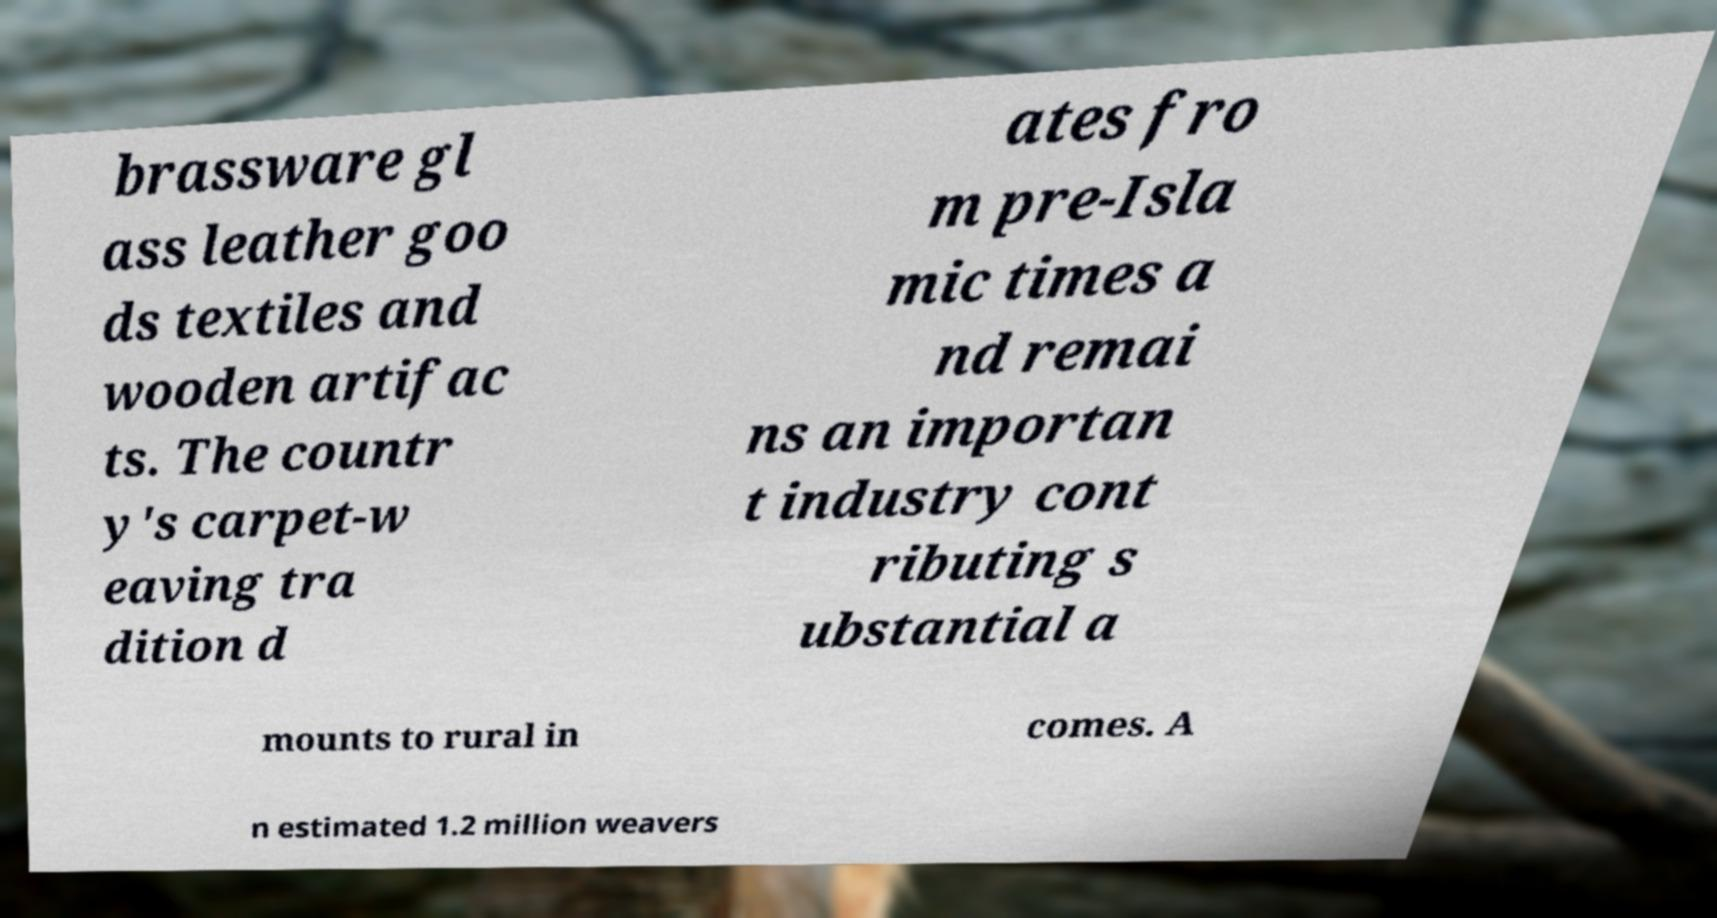Please identify and transcribe the text found in this image. brassware gl ass leather goo ds textiles and wooden artifac ts. The countr y's carpet-w eaving tra dition d ates fro m pre-Isla mic times a nd remai ns an importan t industry cont ributing s ubstantial a mounts to rural in comes. A n estimated 1.2 million weavers 